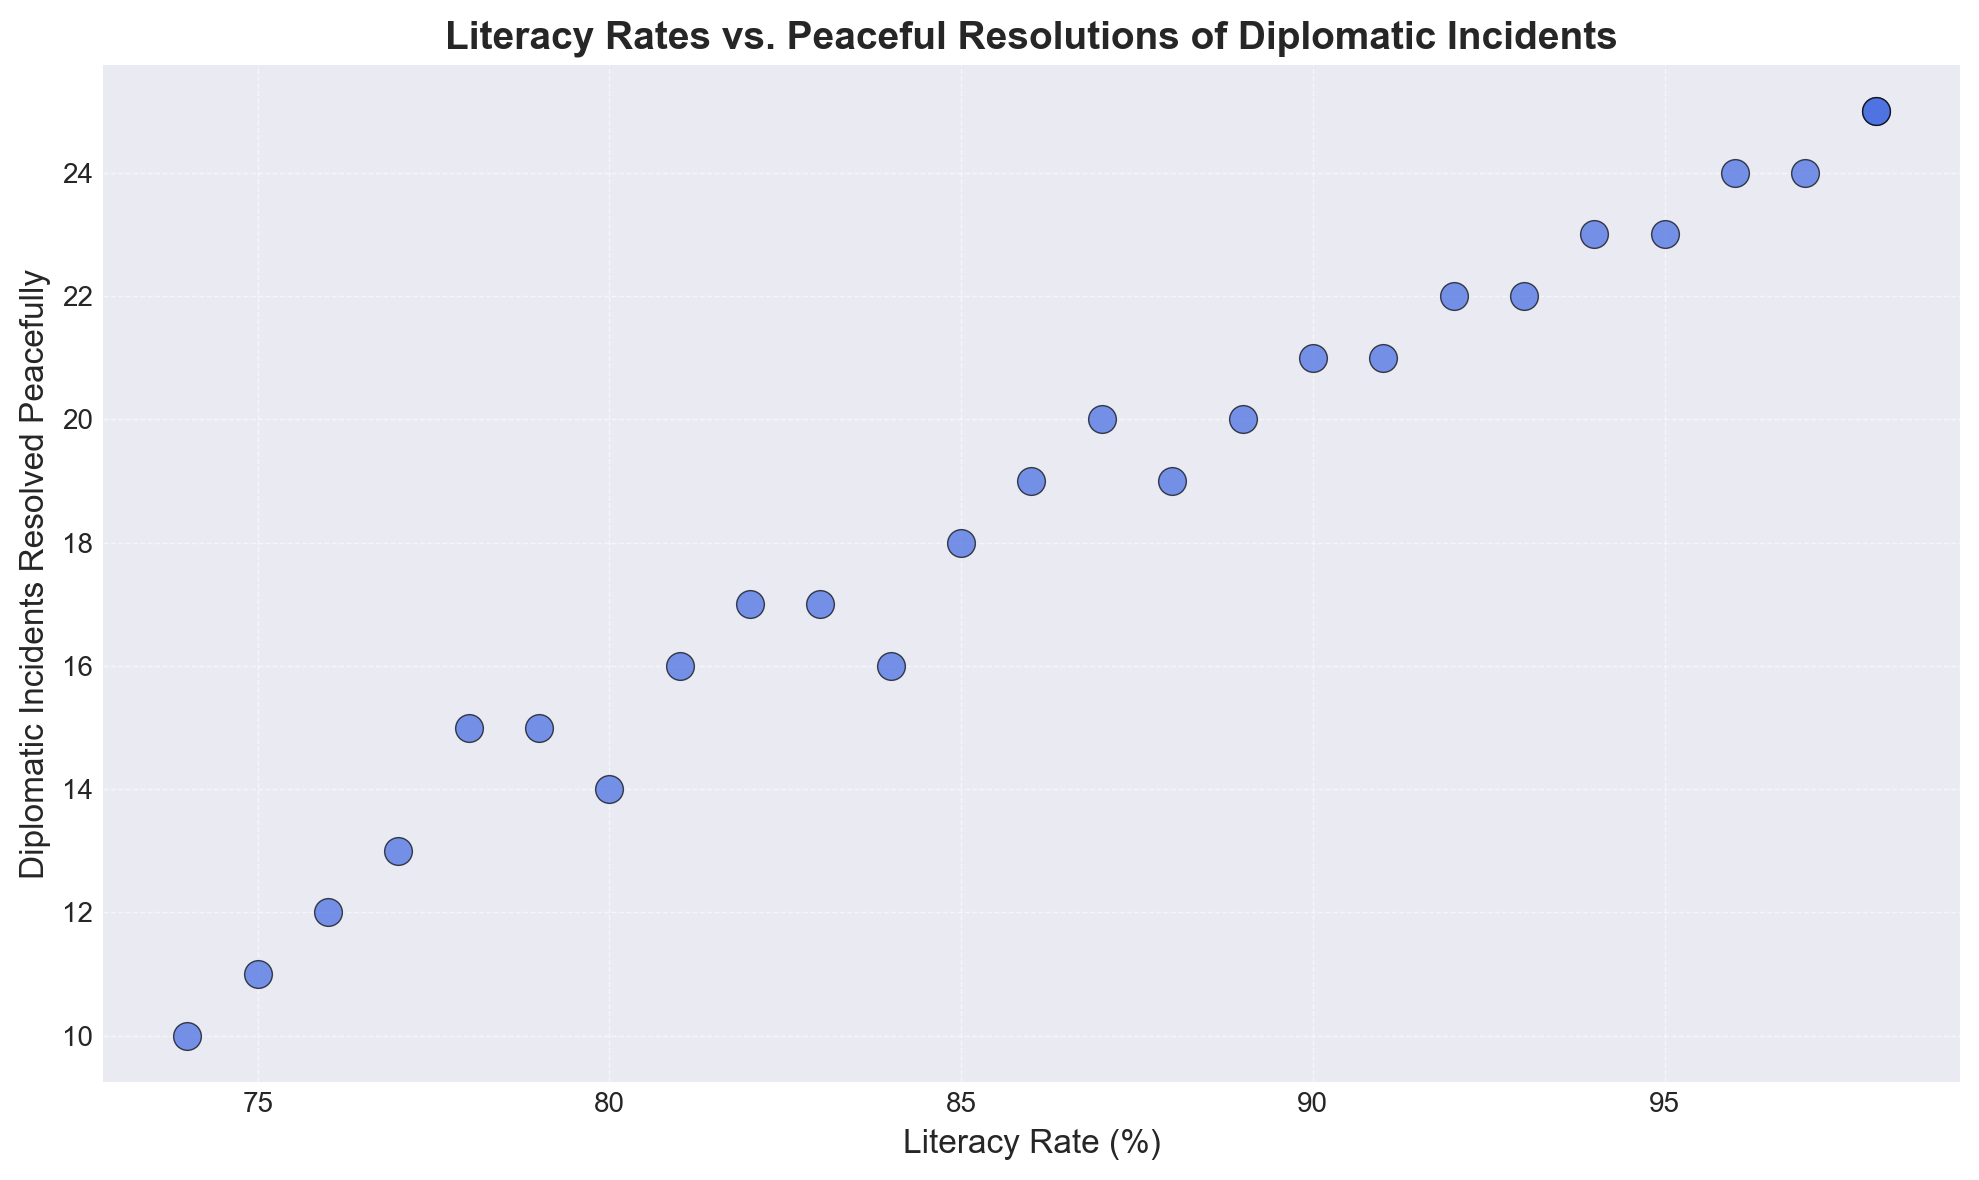What's the correlation between literacy rates and the number of diplomatic incidents resolved peacefully? Visual inspection shows a positive correlation; as literacy rates increase, the number of diplomatic incidents resolved peacefully also tends to increase.
Answer: Positive Which country has the highest literacy rate and how many diplomatic incidents did it resolve peacefully? By inspecting the scatter plot, the point with the highest literacy rate corresponds to Country A and Country Z, both with 98% literacy rates and 25 diplomatic incidents resolved peacefully.
Answer: Country A and Country Z, 25 Is there any country with a literacy rate of 80%? If so, how many diplomatic incidents did it resolve peacefully? Locate the point on the plot where Literacy Rate is 80%. It corresponds to Country L, which resolved 14 diplomatic incidents peacefully.
Answer: Country L, 14 Which country has a literacy rate of 95%, and how does it compare in terms of diplomatic incidents resolved peacefully with the country that has a literacy rate of 97%? Find the points with literacy rates of 95% and 97%. Country G has a literacy rate of 95% resolving 23 incidents, while Country S with 97% resolves 24 incidents.
Answer: Country G, 23 vs. Country S, 24 What is the range of literacy rates among the countries plotted? Identify the minimum and maximum literacy rates. The minimum is 74% (Country D) and the maximum is 98% (Country A and Country Z). The range is 98% - 74%.
Answer: 24% What is the median number of diplomatic incidents resolved peacefully among countries with a literacy rate of 85% or higher? List the number of incidents for countries with literacy rates ≥ 85%: 25, 23, 24, 22, 23, 20, 21, 24, 25, 19. Arrange in order: 19, 20, 21, 22, 23, 23, 24, 24, 25, 25. The median is the average of the 5th and 6th values: (23+23)/2.
Answer: 23 Which country with a literacy rate below 80% managed to resolve the most diplomatic incidents peacefully? Check countries with literacy rates below 80%: Countries D (10), F (15), P (12), Q (13), T (15), Y (11). Country F and T both resolved 15 incidents, the most in this group.
Answer: Country F and Country T, 15 Are there more countries with literacy rates above 90% or below 90%, based on the data provided? Count the number of countries with literacy rates above 90% (8 countries: A, C, G, K, N, R, S, Z) and below 90% (18 countries: B, D, E, F, H, I, J, L, M, O, P, Q, T, U, V, W, X, Y). There are more countries below 90%.
Answer: Below 90% Which countries have resolved exactly 21 diplomatic incidents peacefully, and what are their literacy rates? Find the points with 21 incidents resolved. Countries I and U both resolved 21 incidents. Their literacy rates are 91% and 90%, respectively.
Answer: Country I (91%), Country U (90%) What is the average number of diplomatic incidents resolved peacefully by countries with literacy rates between 75% and 85% inclusive? List incidents for countries with literacy rates between 75% and 85%: 10, 18, 15, 13, 17, 14, 16, 11, 12. Calculate average: (10+18+15+13+17+14+16+11+12)/9 = 14.
Answer: 14 